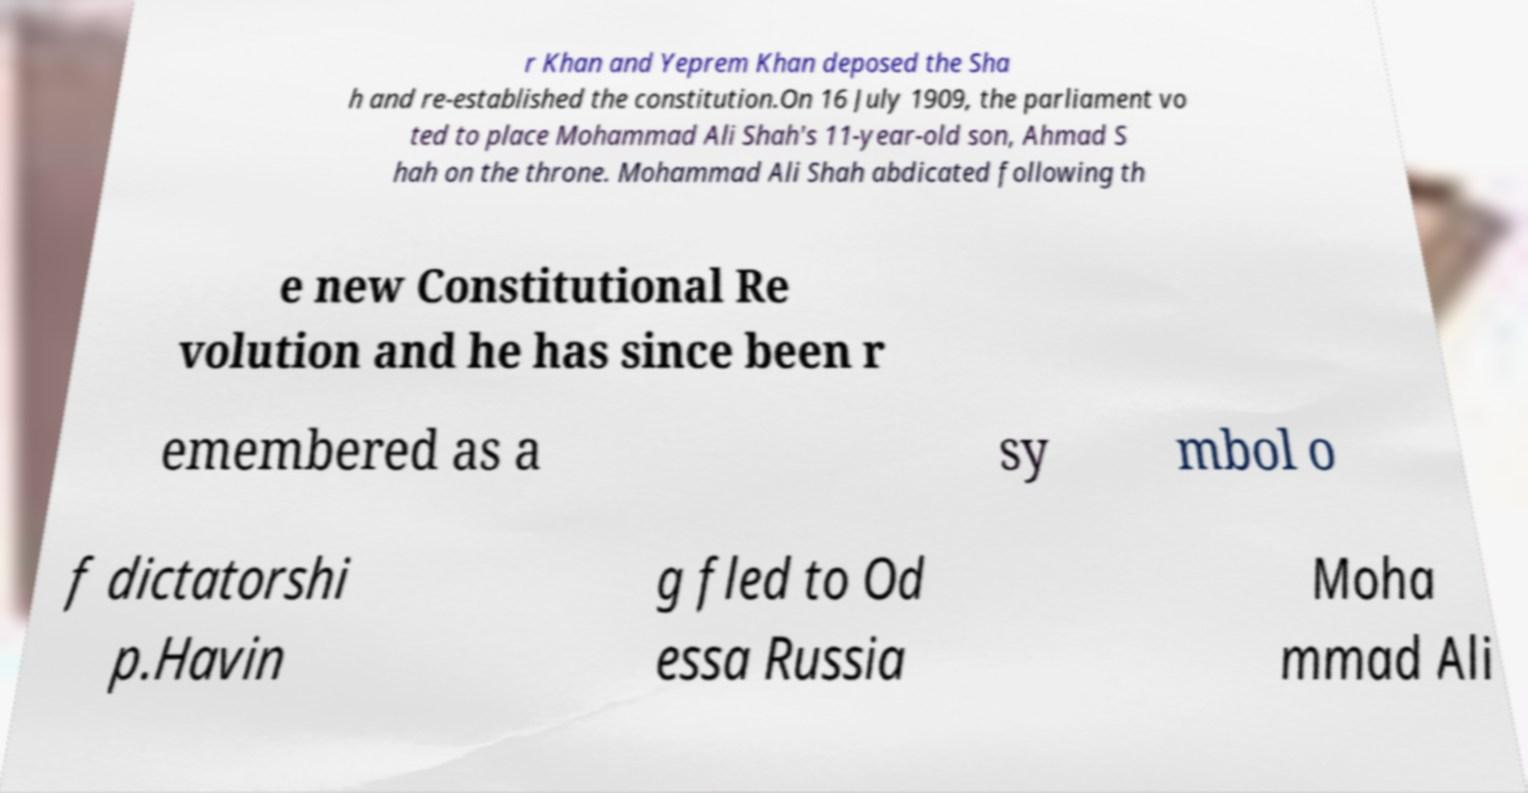For documentation purposes, I need the text within this image transcribed. Could you provide that? r Khan and Yeprem Khan deposed the Sha h and re-established the constitution.On 16 July 1909, the parliament vo ted to place Mohammad Ali Shah's 11-year-old son, Ahmad S hah on the throne. Mohammad Ali Shah abdicated following th e new Constitutional Re volution and he has since been r emembered as a sy mbol o f dictatorshi p.Havin g fled to Od essa Russia Moha mmad Ali 